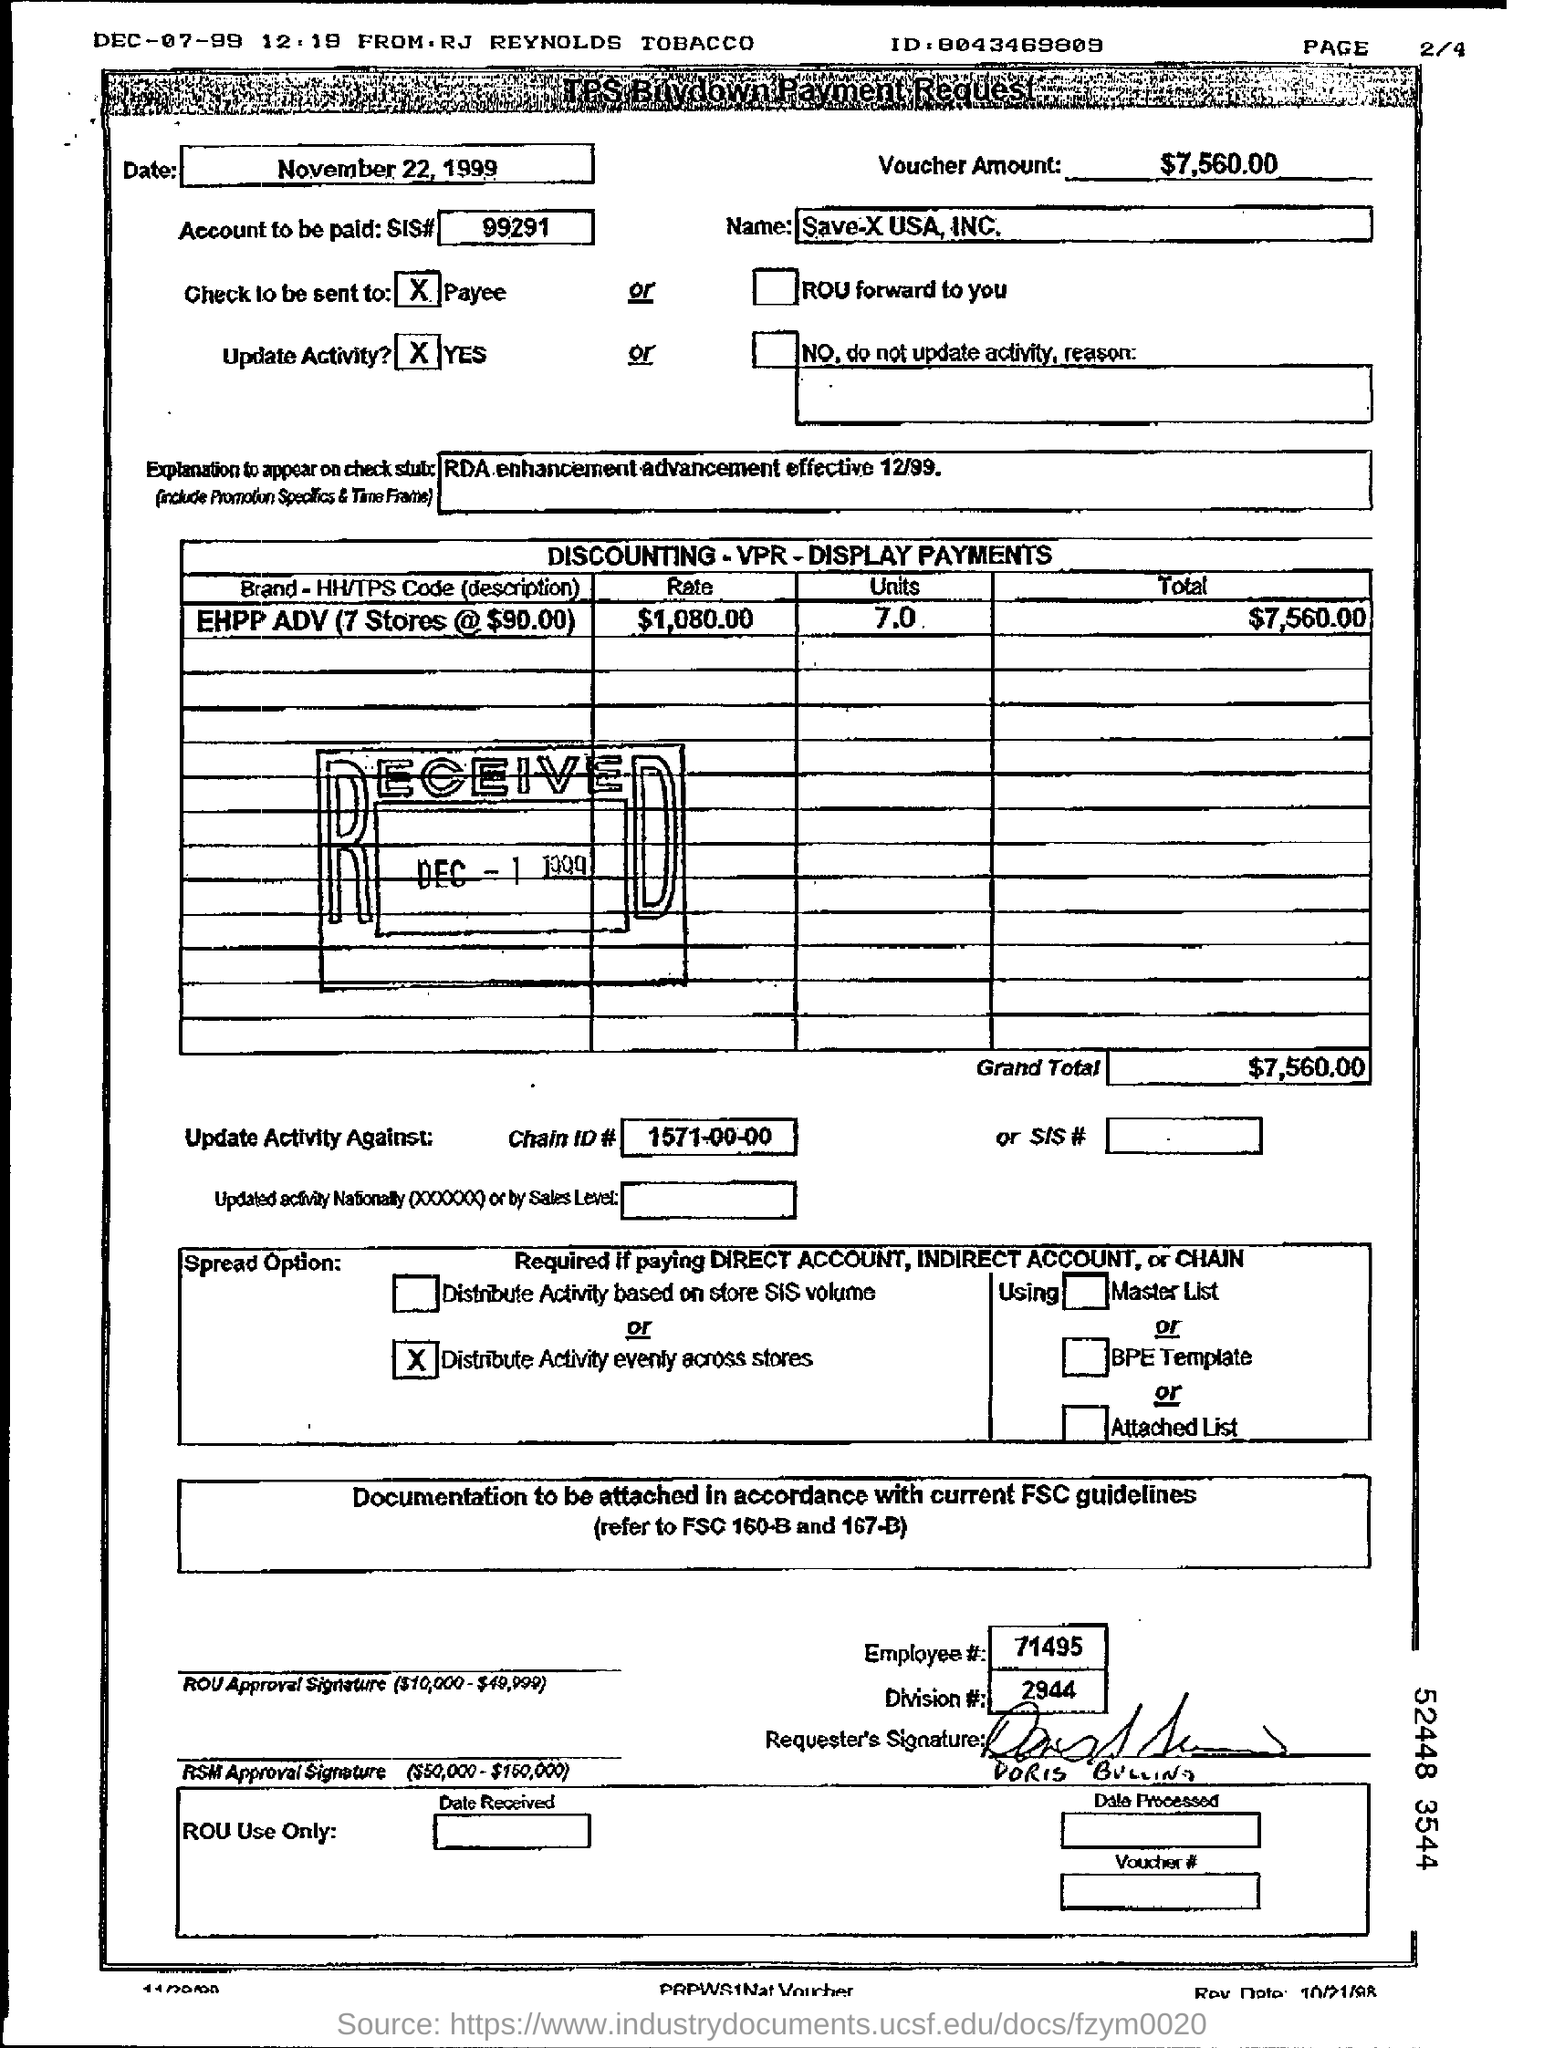Can you explain what the HH/TPS code 'EHPP ADV' might stand for in this context? The HH/TPS code 'EHPP ADV' likely stands for a specific promotional or advertising program, abbreviated as 'EHPP ADV,' tailored to a particular retail setup or marketing campaign. It appears to involve multiple store locations as part of strategic branding or sales efforts. 